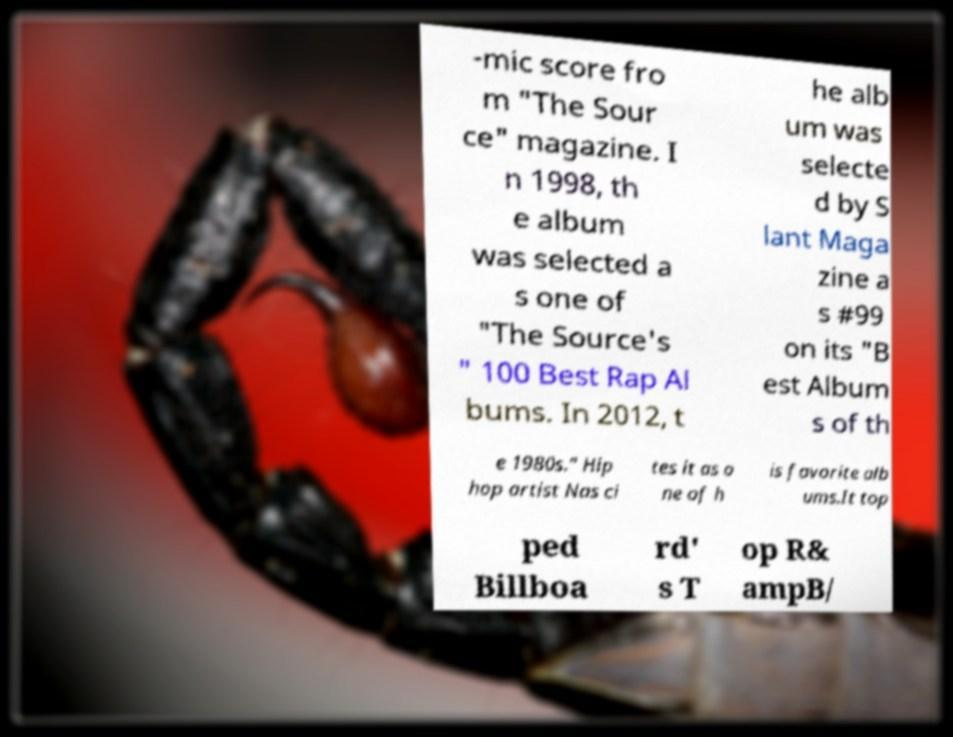Could you extract and type out the text from this image? -mic score fro m "The Sour ce" magazine. I n 1998, th e album was selected a s one of "The Source's " 100 Best Rap Al bums. In 2012, t he alb um was selecte d by S lant Maga zine a s #99 on its "B est Album s of th e 1980s." Hip hop artist Nas ci tes it as o ne of h is favorite alb ums.It top ped Billboa rd' s T op R& ampB/ 